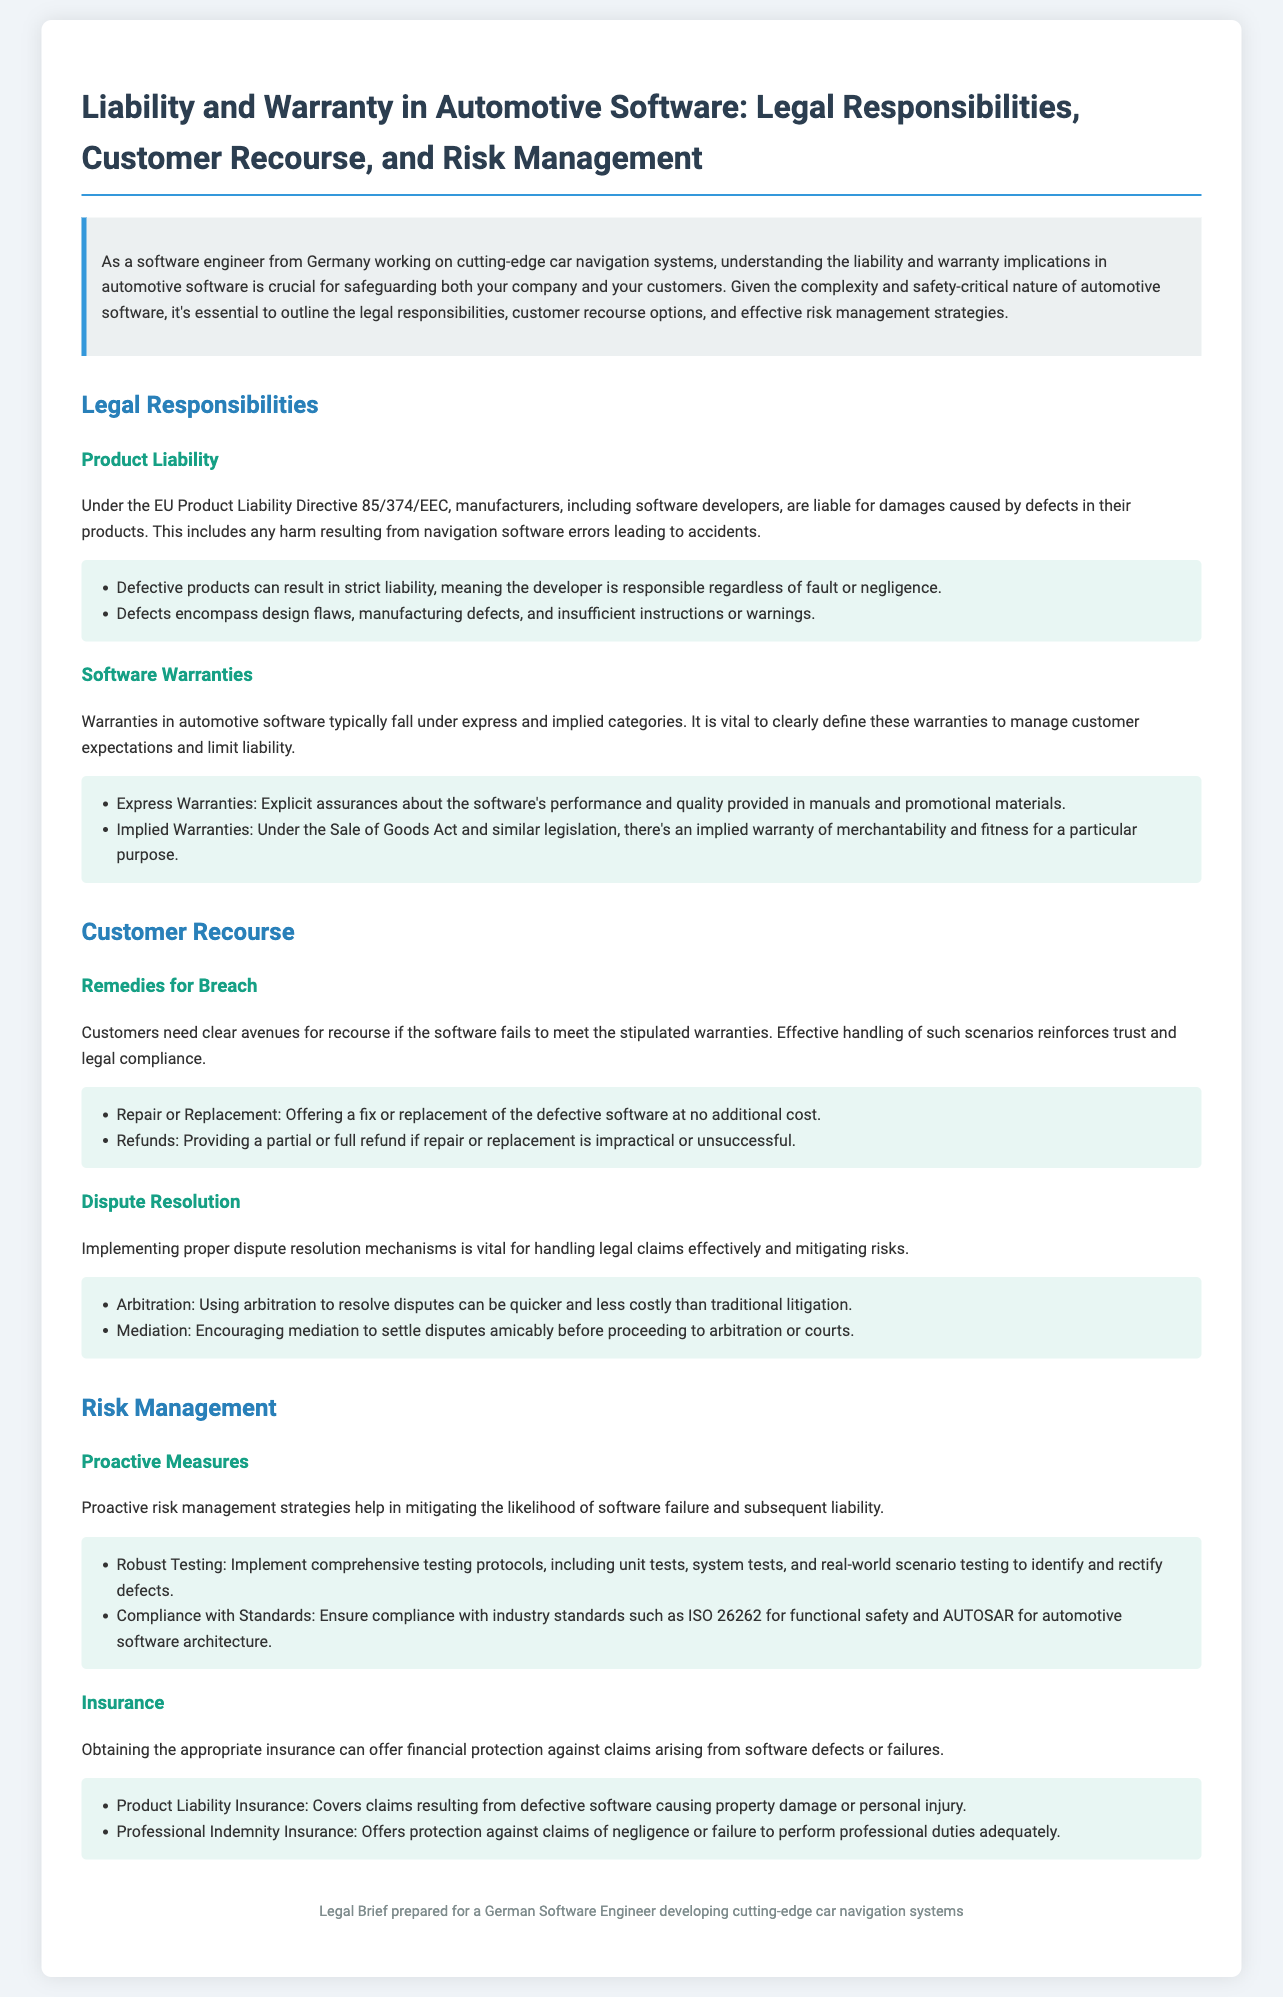What is the title of the document? The title of the document is stated at the top of the rendered content.
Answer: Liability and Warranty in Automotive Software: Legal Responsibilities, Customer Recourse, and Risk Management What directive governs product liability in the EU? The document cites the governing directive for product liability within the EU.
Answer: EU Product Liability Directive 85/374/EEC What are the two types of warranties mentioned? The document lists the categories of warranties relevant to automotive software.
Answer: Express and implied What is a remedy for breach stated in the document? The document indicates remedies available to customers when warranties are breached.
Answer: Repair or Replacement Which method is suggested for dispute resolution? The document outlines strategies for dispute resolution in legal claims.
Answer: Arbitration What insurance covers claims arising from defective software? The document specifies types of insurance important for mitigating risk in automotive software.
Answer: Product Liability Insurance What proactive measure is suggested to manage risks? The document highlights actions that can be taken to minimize the risk of software failures.
Answer: Robust Testing What does the document say about mediating disputes? The document discusses means for settling disputes amicably before escalating to further legal actions.
Answer: Encouraging mediation What is the purpose of Professional Indemnity Insurance? The document explains the protection offered by professional indemnity insurance.
Answer: Protection against claims of negligence 